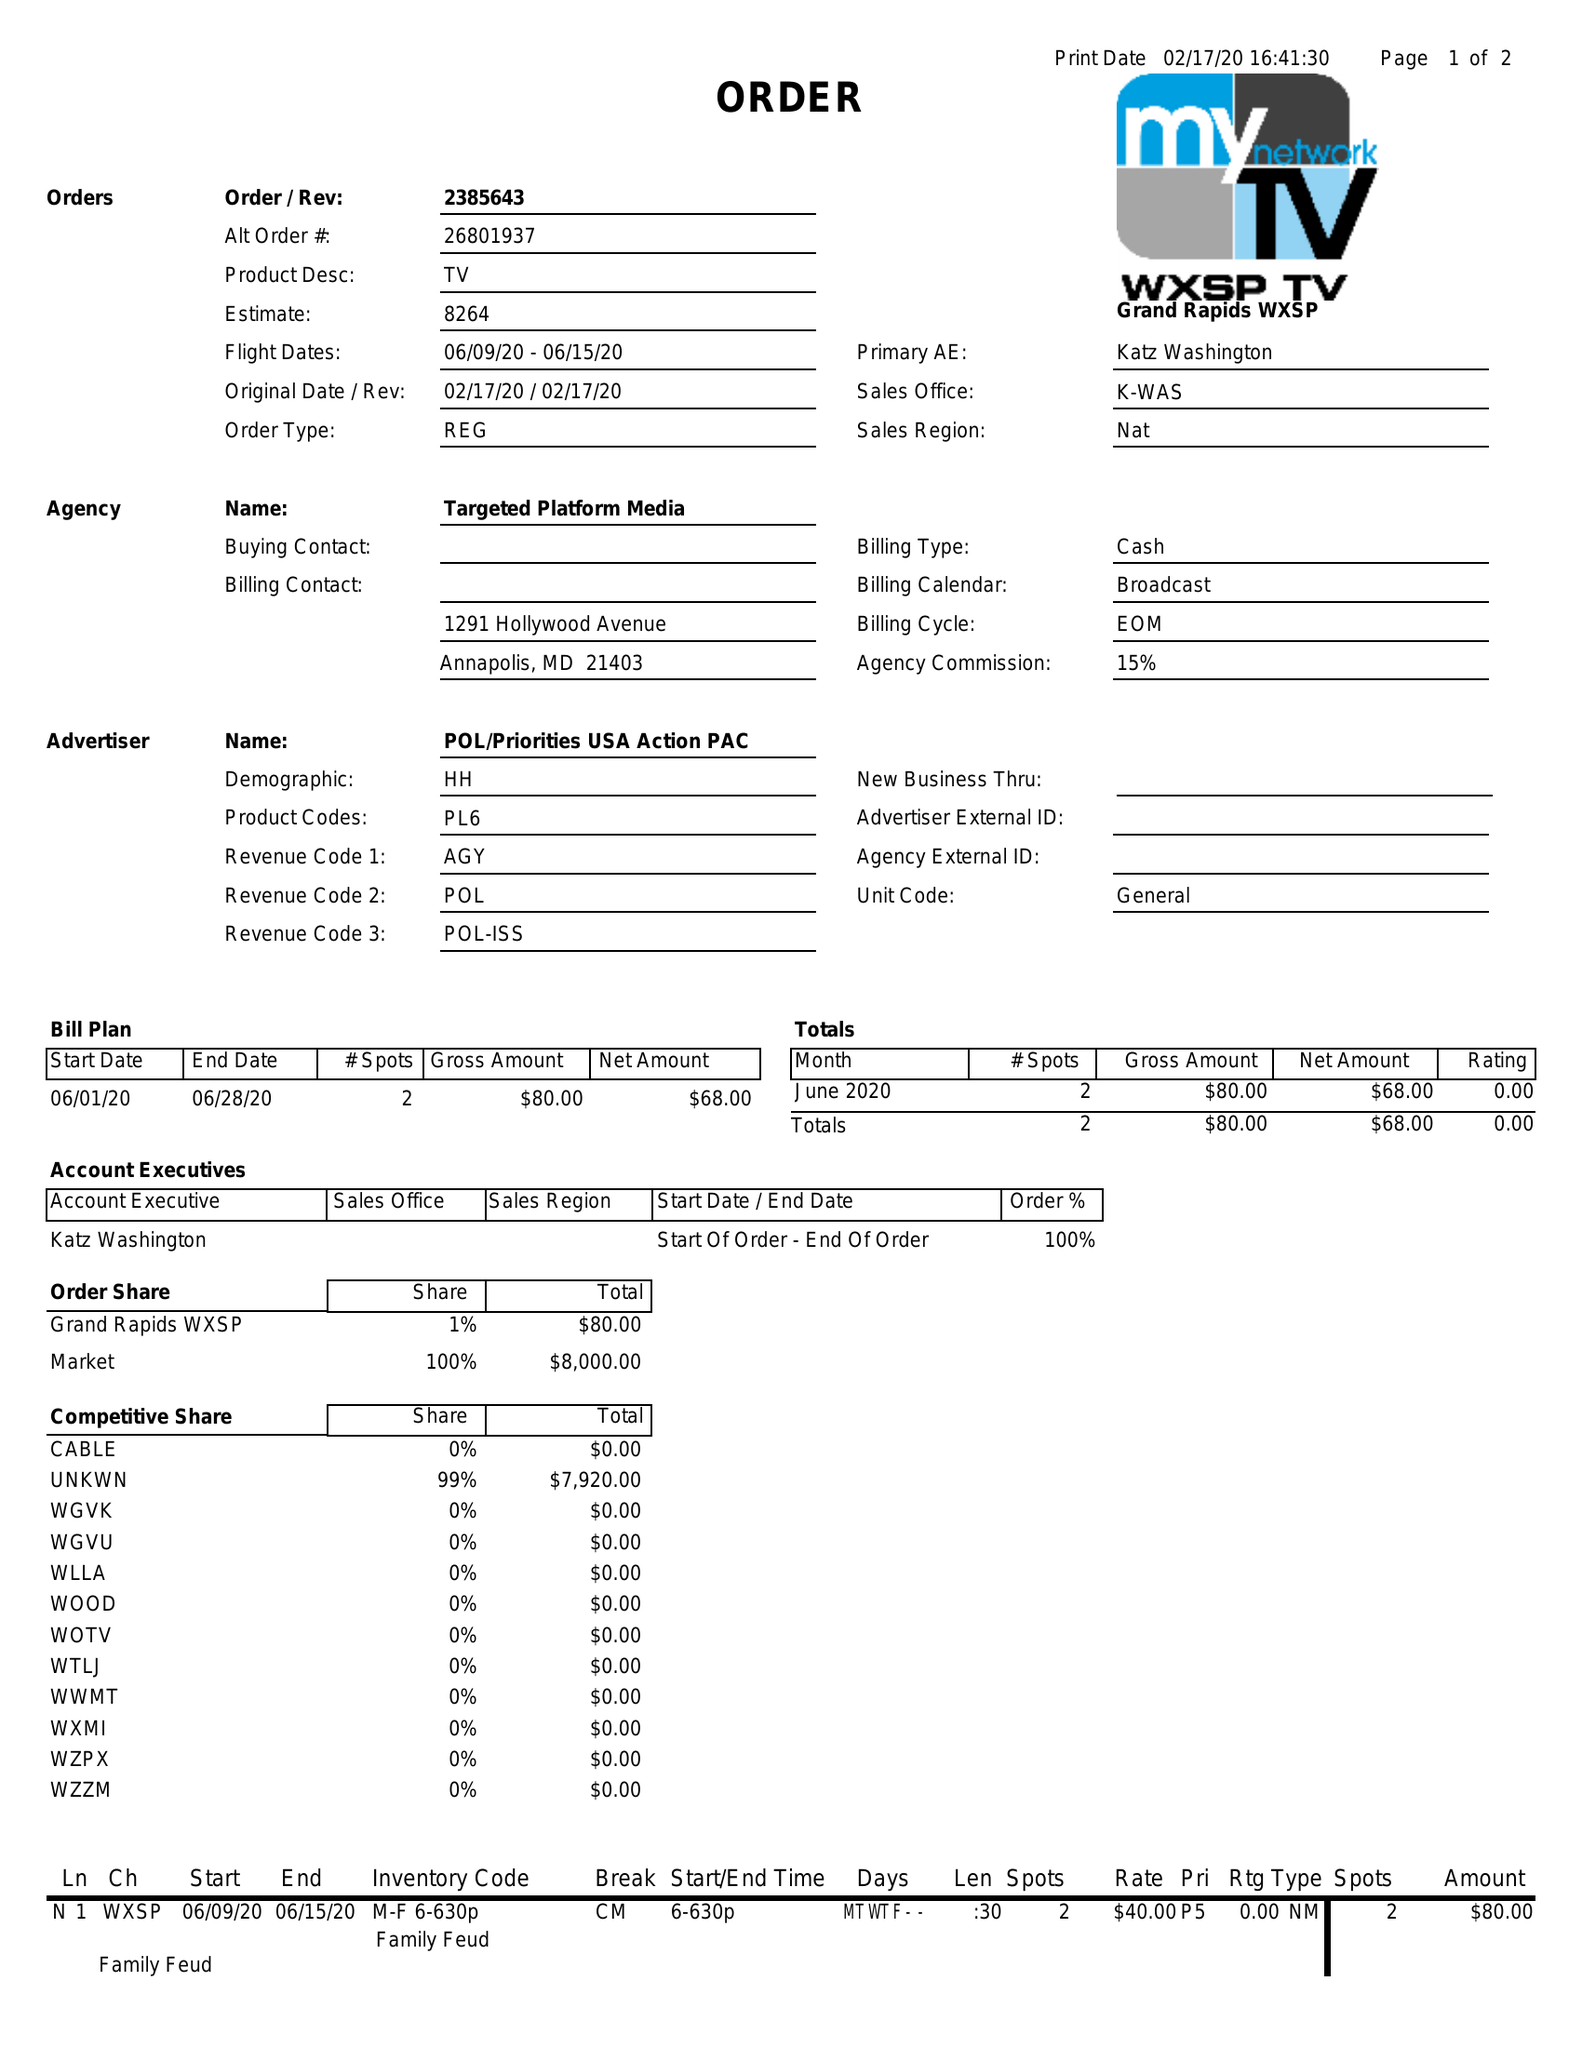What is the value for the gross_amount?
Answer the question using a single word or phrase. 80.00 